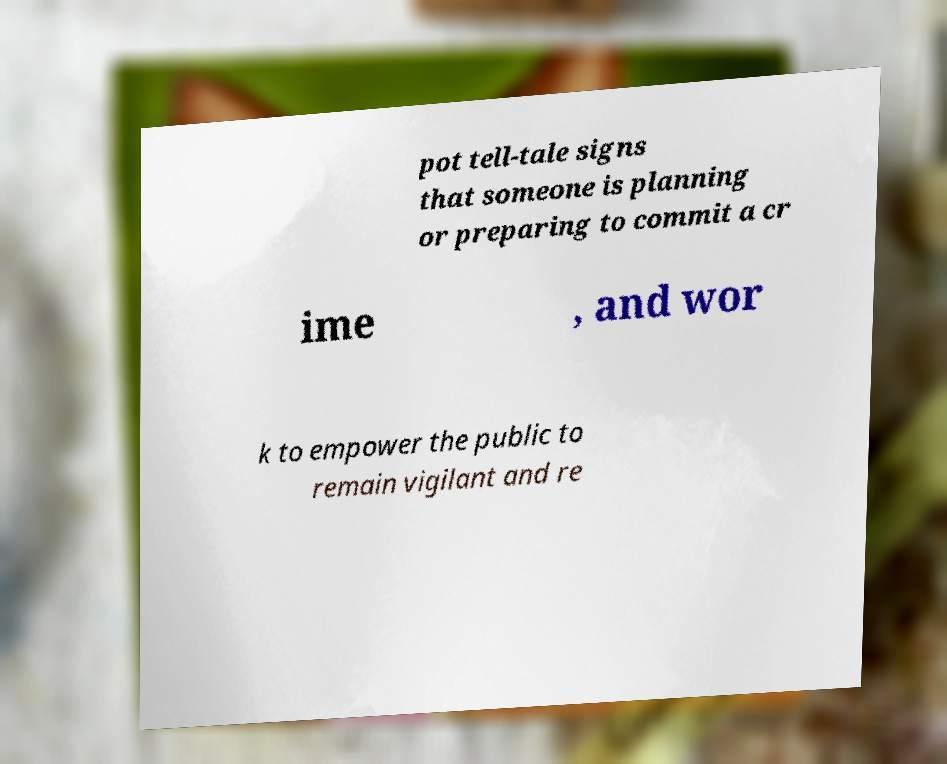Could you extract and type out the text from this image? pot tell-tale signs that someone is planning or preparing to commit a cr ime , and wor k to empower the public to remain vigilant and re 